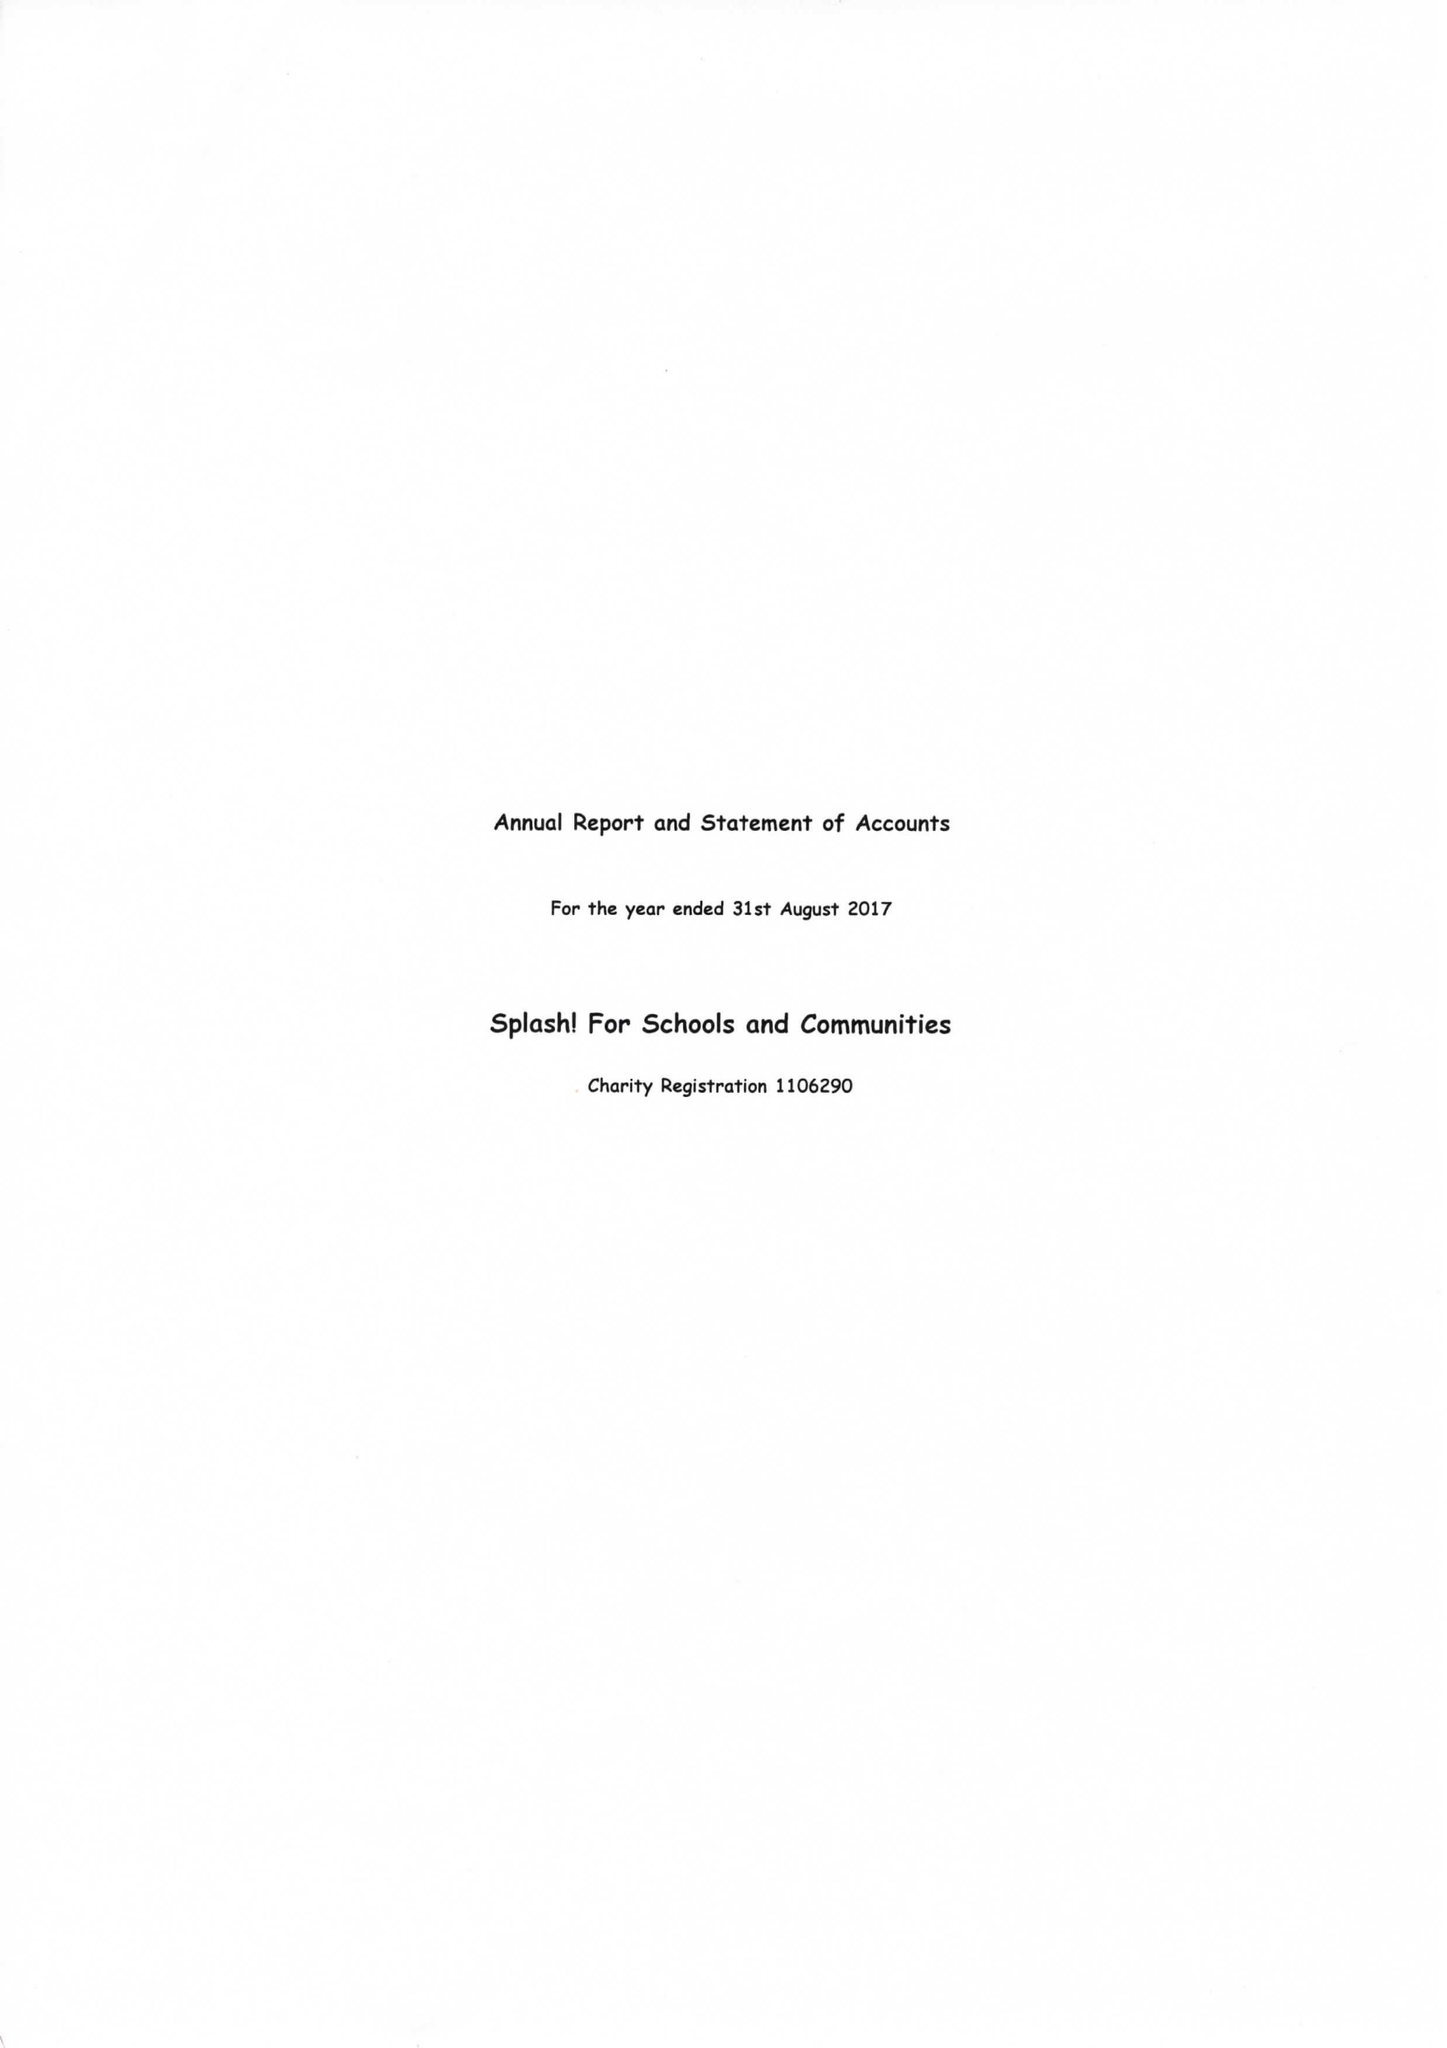What is the value for the address__street_line?
Answer the question using a single word or phrase. None 